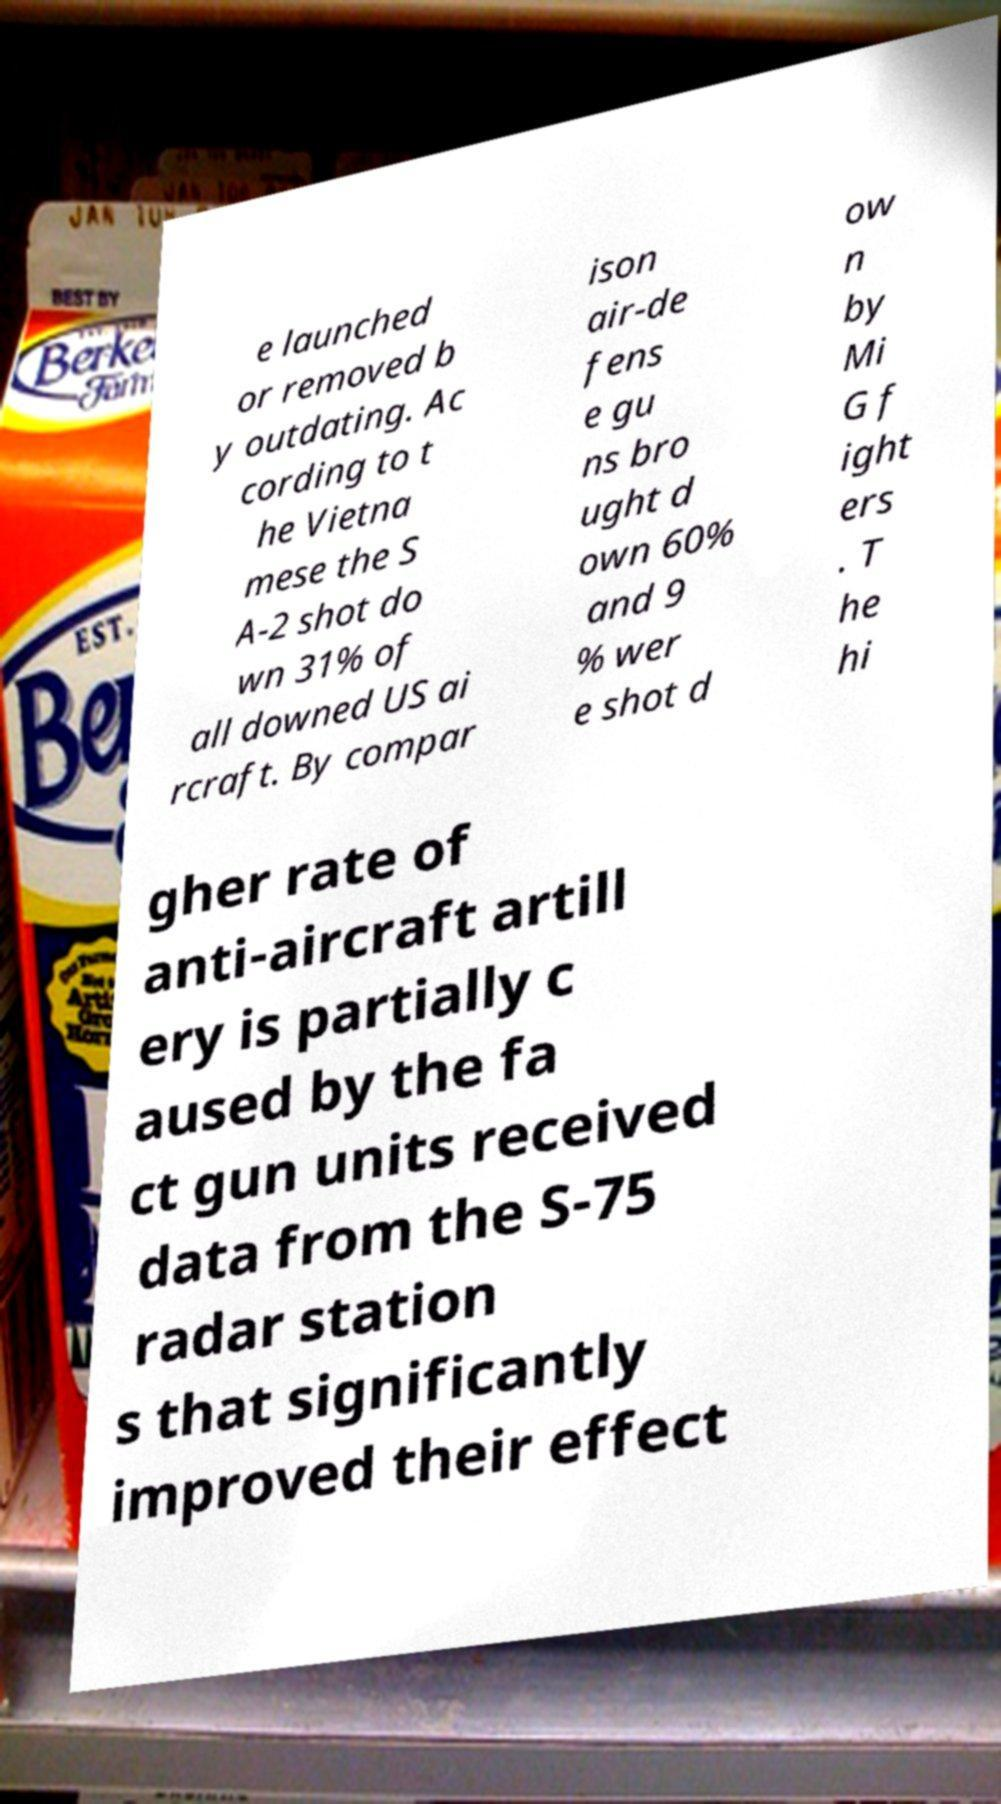Please identify and transcribe the text found in this image. e launched or removed b y outdating. Ac cording to t he Vietna mese the S A-2 shot do wn 31% of all downed US ai rcraft. By compar ison air-de fens e gu ns bro ught d own 60% and 9 % wer e shot d ow n by Mi G f ight ers . T he hi gher rate of anti-aircraft artill ery is partially c aused by the fa ct gun units received data from the S-75 radar station s that significantly improved their effect 